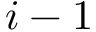<formula> <loc_0><loc_0><loc_500><loc_500>i - 1</formula> 